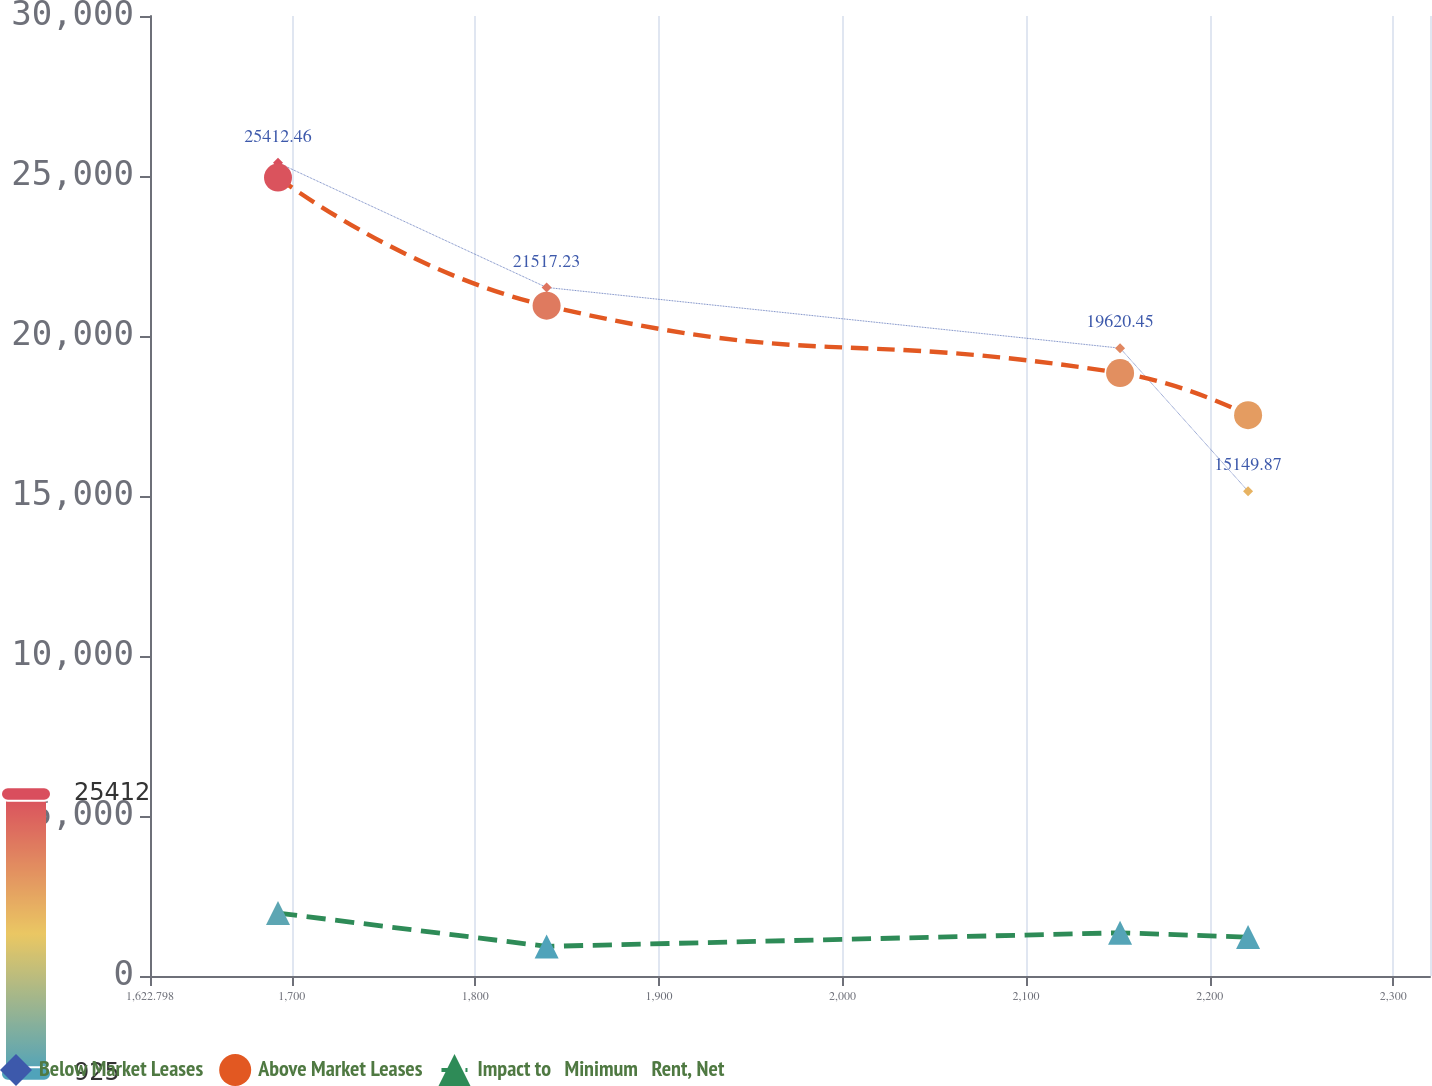Convert chart. <chart><loc_0><loc_0><loc_500><loc_500><line_chart><ecel><fcel>Below Market Leases<fcel>Above Market Leases<fcel>Impact to   Minimum   Rent, Net<nl><fcel>1692.52<fcel>25412.5<fcel>24951.9<fcel>1965.66<nl><fcel>1838.83<fcel>21517.2<fcel>20946.5<fcel>925.36<nl><fcel>2151.21<fcel>19620.5<fcel>18842.5<fcel>1349.85<nl><fcel>2220.93<fcel>15149.9<fcel>17526.4<fcel>1215.08<nl><fcel>2389.74<fcel>6444.7<fcel>11790.7<fcel>2273.06<nl></chart> 